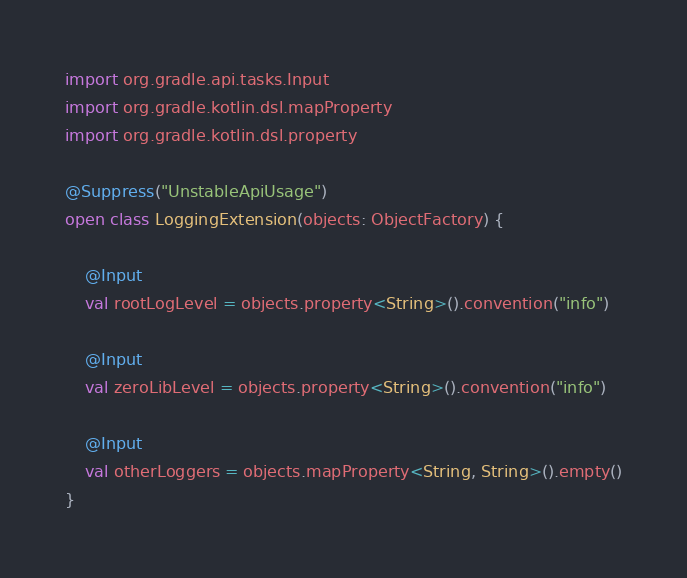Convert code to text. <code><loc_0><loc_0><loc_500><loc_500><_Kotlin_>import org.gradle.api.tasks.Input
import org.gradle.kotlin.dsl.mapProperty
import org.gradle.kotlin.dsl.property

@Suppress("UnstableApiUsage")
open class LoggingExtension(objects: ObjectFactory) {

    @Input
    val rootLogLevel = objects.property<String>().convention("info")

    @Input
    val zeroLibLevel = objects.property<String>().convention("info")

    @Input
    val otherLoggers = objects.mapProperty<String, String>().empty()
}

</code> 